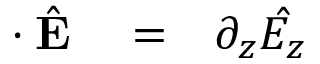<formula> <loc_0><loc_0><loc_500><loc_500>\begin{array} { r l r } { { \nabla } \cdot \hat { E } } & = } & { \partial _ { z } \hat { E _ { z } } } \end{array}</formula> 